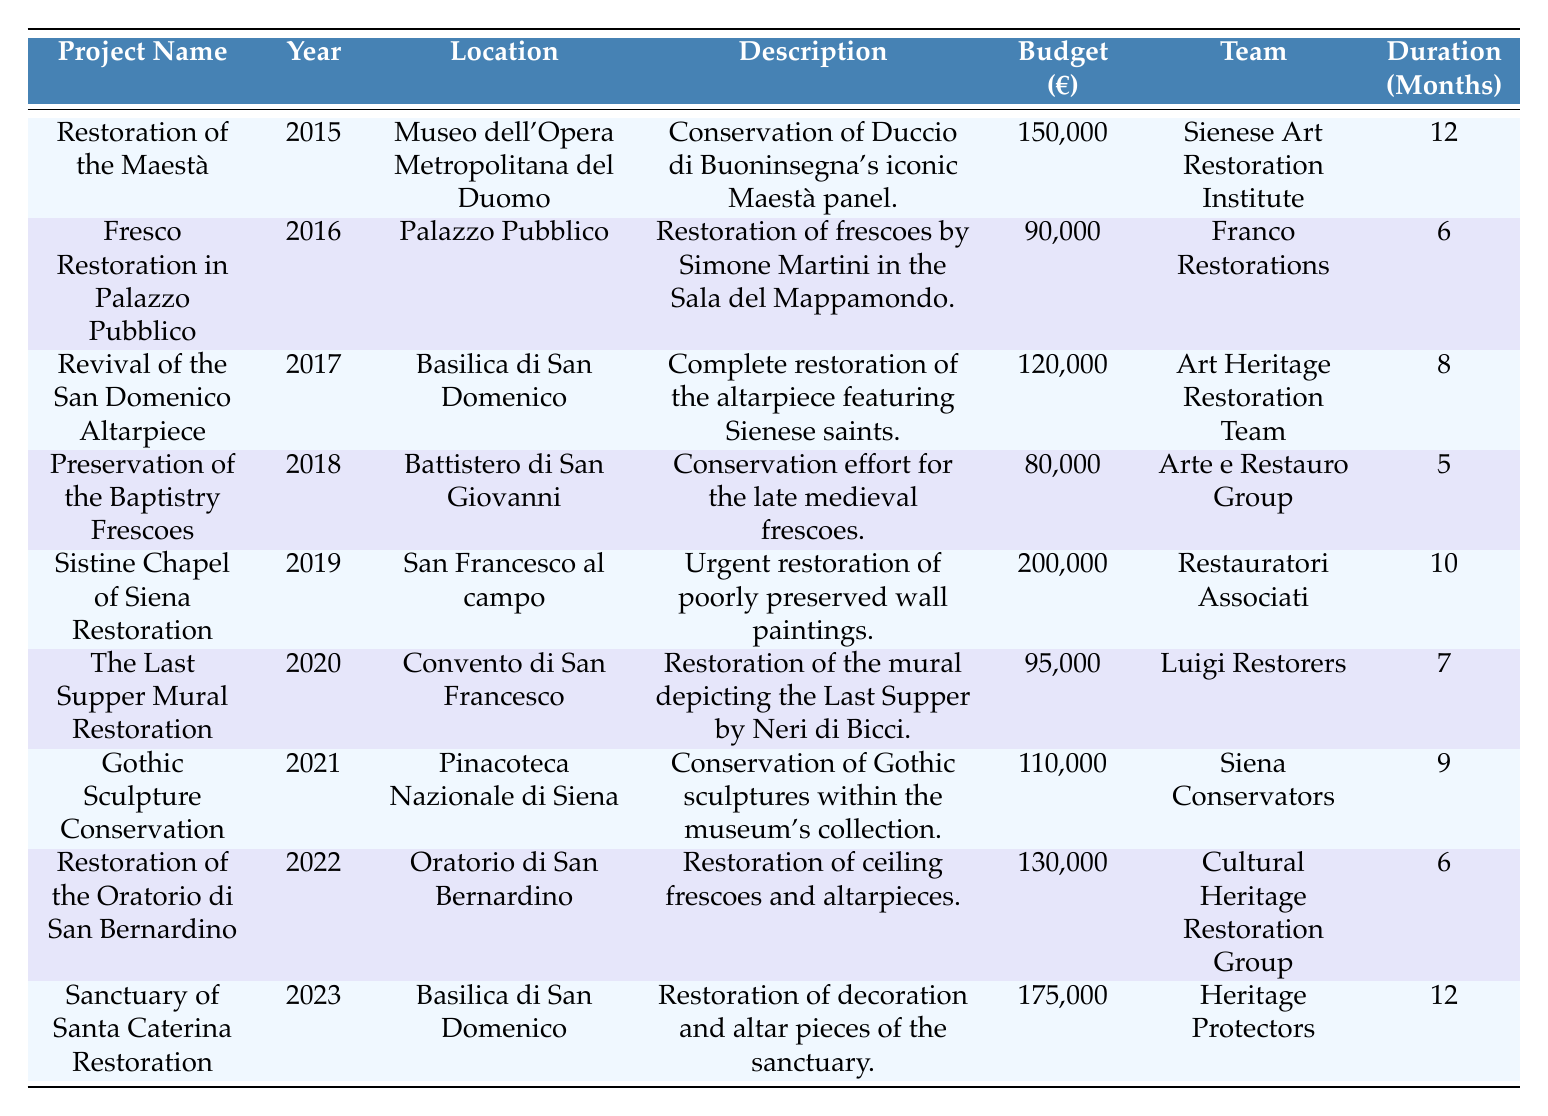What is the total budget allocated for art restoration projects in Siena from 2015 to 2023? The budgets for the projects listed in the table are: 150,000 (2015) + 90,000 (2016) + 120,000 (2017) + 80,000 (2018) + 200,000 (2019) + 95,000 (2020) + 110,000 (2021) + 130,000 (2022) + 175,000 (2023) = 1,120,000.
Answer: 1,120,000 Which project had the shortest duration, and how long did it take? The project with the shortest duration is the Preservation of the Baptistry Frescoes (2018), which took 5 months.
Answer: 5 months What is the average duration of all restoration projects? The durations of the projects are: 12, 6, 8, 5, 10, 7, 9, 6, 12. There are 9 projects, and their total duration is 12 + 6 + 8 + 5 + 10 + 7 + 9 + 6 + 12 = 69. The average duration is 69 / 9 ≈ 7.67 months.
Answer: 7.67 months Did any art restoration project surpass a budget of €200,000? According to the table, the highest project budget is €200,000 for the Sistine Chapel of Siena Restoration (2019), which meets this criterion.
Answer: Yes How many restoration projects were completed in Basilica di San Domenico? There are two projects listed under Basilica di San Domenico: the Revival of the San Domenico Altarpiece (2017) and the Sanctuary of Santa Caterina Restoration (2023).
Answer: 2 What was the total duration of projects led by the Sienese Art Restoration Institute? Only one project, the Restoration of the Maestà in 2015, was conducted by the Sienese Art Restoration Institute with a duration of 12 months.
Answer: 12 months Which year had the highest budget allocation for restoration projects? The year 2019 had the highest budget, recorded at €200,000 for the Sistine Chapel of Siena Restoration project.
Answer: 2019 Is there any project that was completed in less than 6 months? Yes, the Preservation of the Baptistry Frescoes (2018) was completed in 5 months, which is less than 6 months.
Answer: Yes What percentage of the total projects were conducted in Palazzo Pubblico? There is one project, Fresco Restoration in Palazzo Pubblico (2016), out of a total of 9 projects, which is (1/9) * 100 ≈ 11.11%.
Answer: 11.11% How much was spent on projects located in Basilica di San Domenico? The Revival of the San Domenico Altarpiece (2017) had a budget of €120,000 and the Sanctuary of Santa Caterina Restoration (2023) had €175,000, for a total of €120,000 + €175,000 = €295,000.
Answer: 295,000 